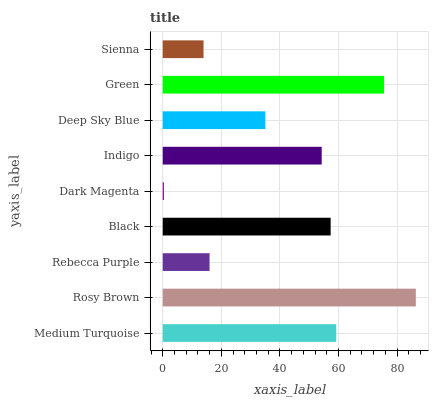Is Dark Magenta the minimum?
Answer yes or no. Yes. Is Rosy Brown the maximum?
Answer yes or no. Yes. Is Rebecca Purple the minimum?
Answer yes or no. No. Is Rebecca Purple the maximum?
Answer yes or no. No. Is Rosy Brown greater than Rebecca Purple?
Answer yes or no. Yes. Is Rebecca Purple less than Rosy Brown?
Answer yes or no. Yes. Is Rebecca Purple greater than Rosy Brown?
Answer yes or no. No. Is Rosy Brown less than Rebecca Purple?
Answer yes or no. No. Is Indigo the high median?
Answer yes or no. Yes. Is Indigo the low median?
Answer yes or no. Yes. Is Black the high median?
Answer yes or no. No. Is Green the low median?
Answer yes or no. No. 